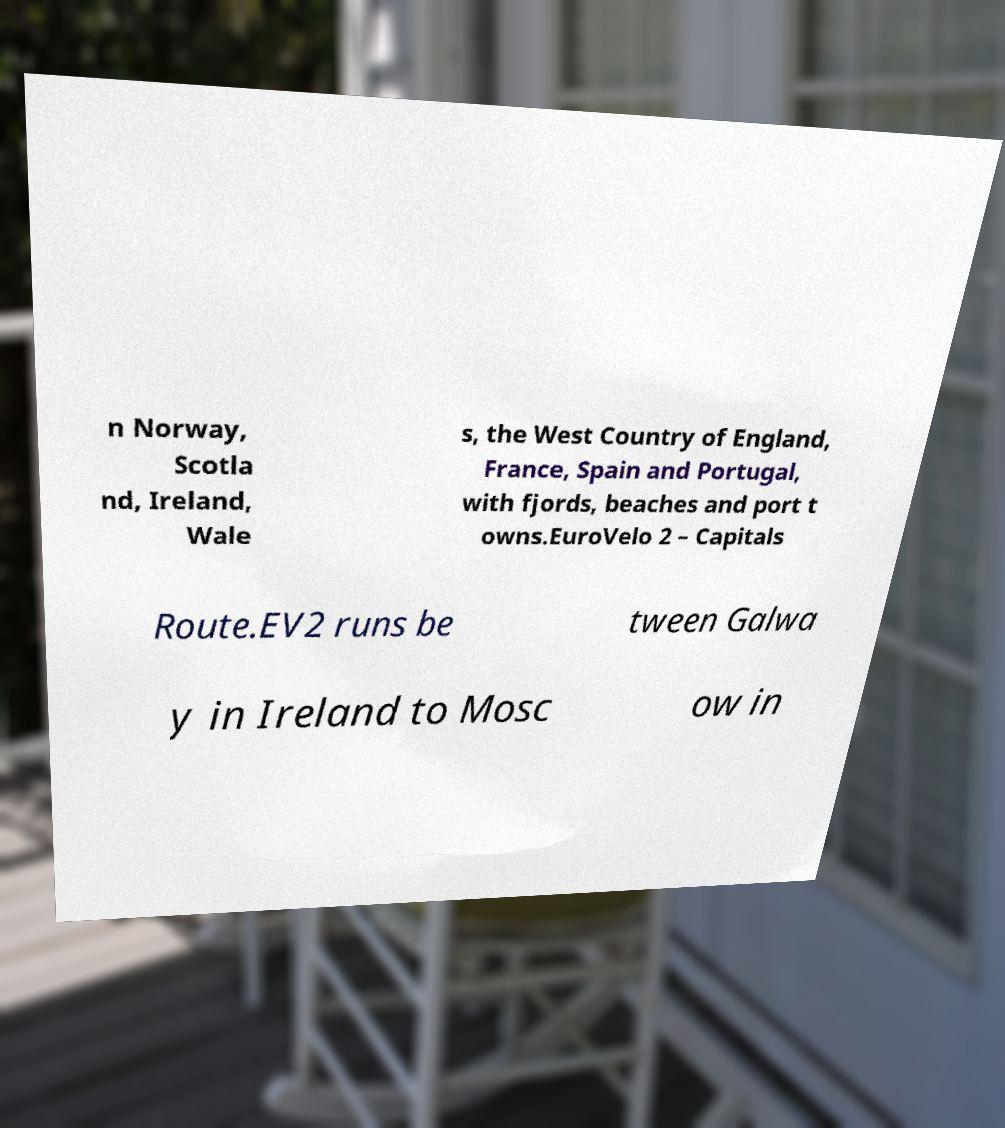There's text embedded in this image that I need extracted. Can you transcribe it verbatim? n Norway, Scotla nd, Ireland, Wale s, the West Country of England, France, Spain and Portugal, with fjords, beaches and port t owns.EuroVelo 2 – Capitals Route.EV2 runs be tween Galwa y in Ireland to Mosc ow in 